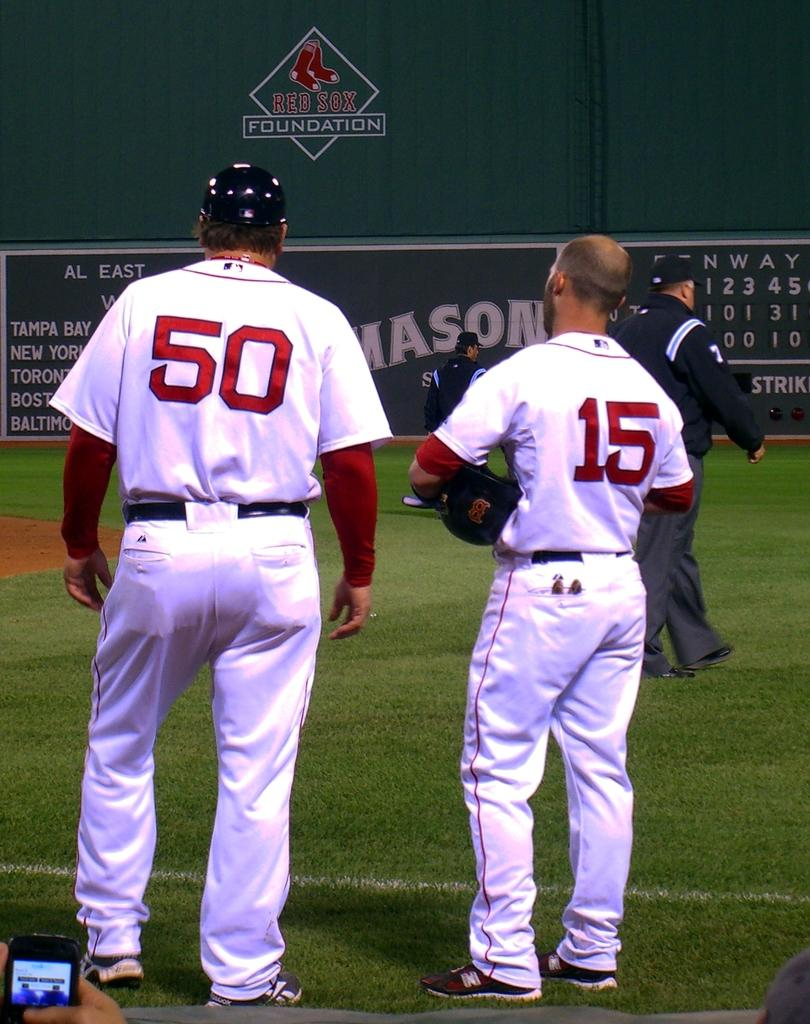<image>
Create a compact narrative representing the image presented. Baseball players 50 and 15 at the Red Sox Foundation evet 